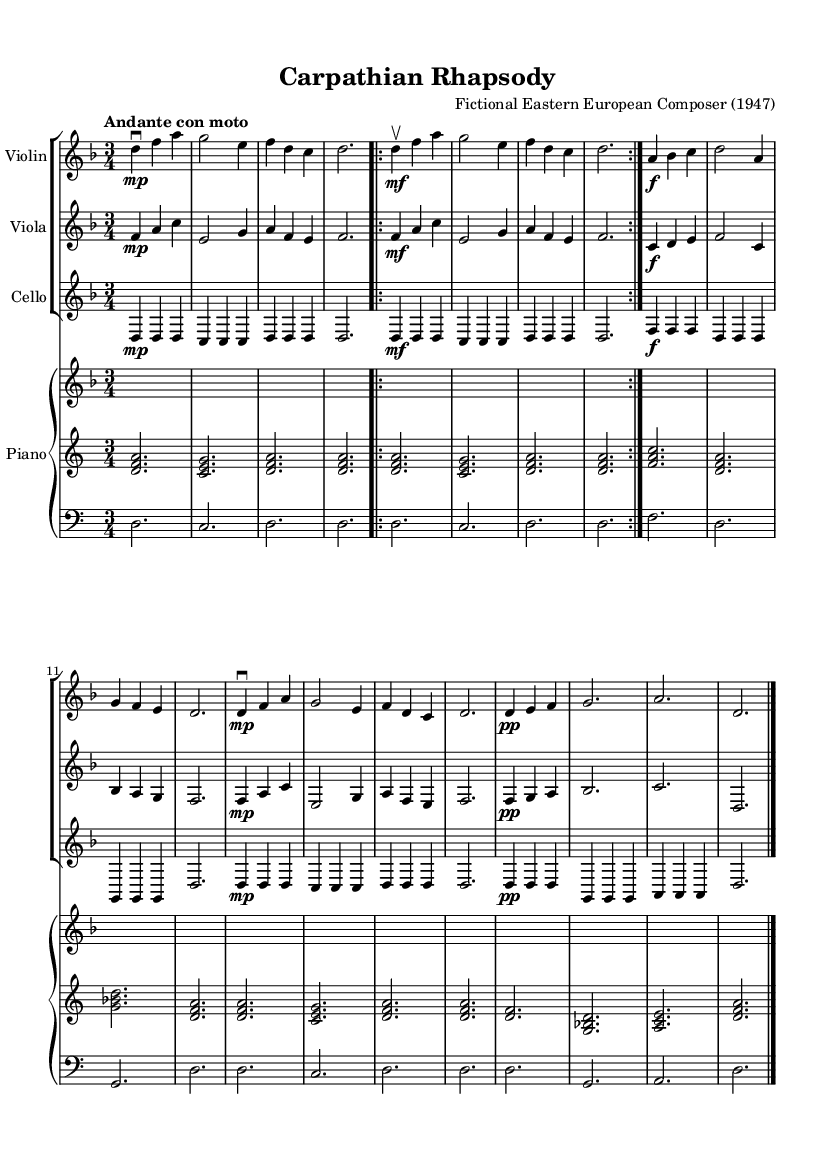What is the key signature of this music? The key signature is indicated at the beginning of the staff. There is one flat, which means the piece is in D minor.
Answer: D minor What is the time signature of this music? The time signature is also displayed at the beginning of the piece. It shows 3/4, indicating three beats in each measure and a quarter note gets one beat.
Answer: 3/4 What is the tempo marking of the piece? The tempo marking is found above the staff. It specifies the speed and is written as "Andante con moto," which means moderately slow with motion.
Answer: Andante con moto How many measures are in Theme A? Theme A is indicated in the sheet music as the section where the folk melody is presented. It consists of two repetitions of a four-measure phrase, totaling eight measures.
Answer: Eight measures What dynamics are indicated for the Coda section? The Coda section contains dynamic markings. It is marked to start at pp (piano piano) signifying very soft, before moving to a final f (forte) at the end.
Answer: pp to f What type of musical form is used in this composition? The composition displays characteristics of a Theme and Variations form. The return of Theme A after Theme B represents the variation on the original folk melody.
Answer: Theme and Variations Which instrument is playing the main thematic material? The main thematic material in this piece is primarily played by the violin, which carries the folk melody throughout the piece.
Answer: Violin 